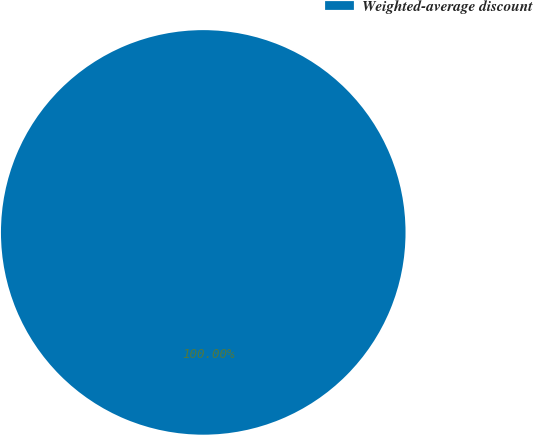<chart> <loc_0><loc_0><loc_500><loc_500><pie_chart><fcel>Weighted-average discount<nl><fcel>100.0%<nl></chart> 